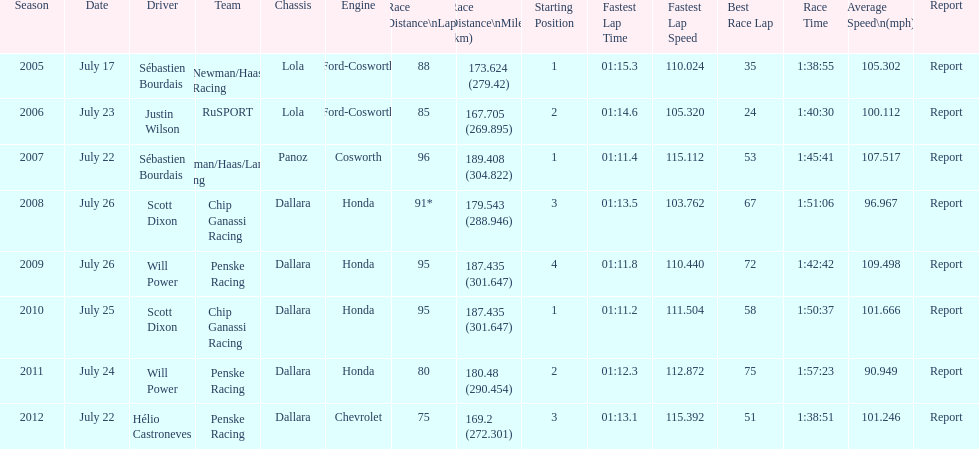What is the least amount of laps completed? 75. 